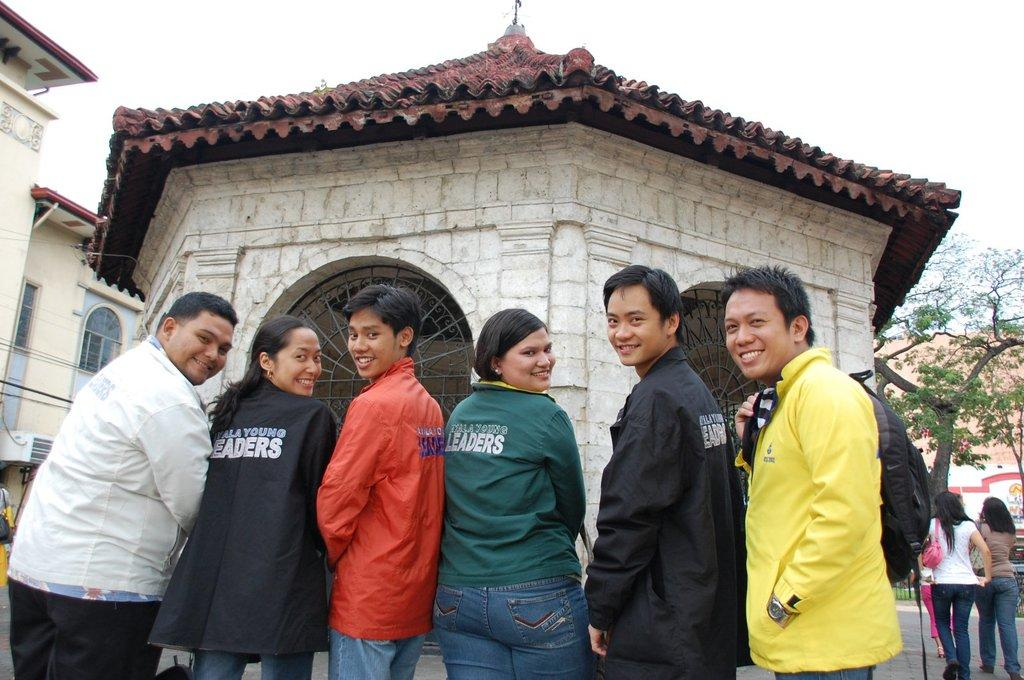How many people are in the image? There is a group of people in the image. What is located on the right side of the image? There is a tree on the right side of the image. What can be seen in the background of the image? There are buildings and the sky visible in the background of the image. Where is the scarecrow located in the image? There is no scarecrow present in the image. Can you tell me how many dogs are in the image? There are no dogs present in the image. 